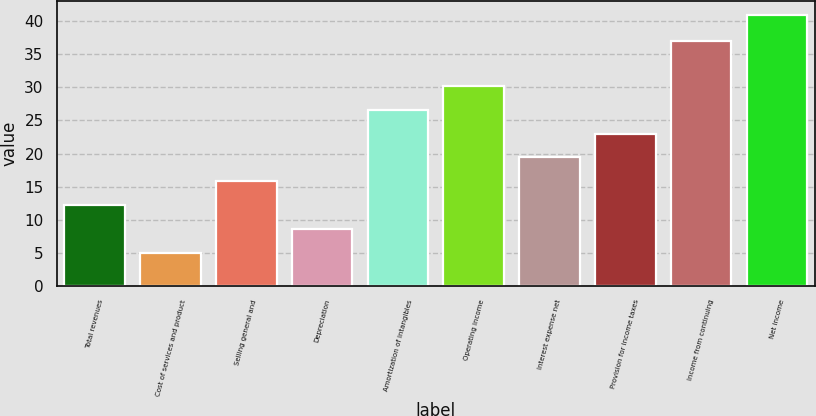<chart> <loc_0><loc_0><loc_500><loc_500><bar_chart><fcel>Total revenues<fcel>Cost of services and product<fcel>Selling general and<fcel>Depreciation<fcel>Amortization of intangibles<fcel>Operating income<fcel>Interest expense net<fcel>Provision for income taxes<fcel>Income from continuing<fcel>Net income<nl><fcel>12.2<fcel>5<fcel>15.8<fcel>8.6<fcel>26.6<fcel>30.2<fcel>19.4<fcel>23<fcel>37<fcel>41<nl></chart> 